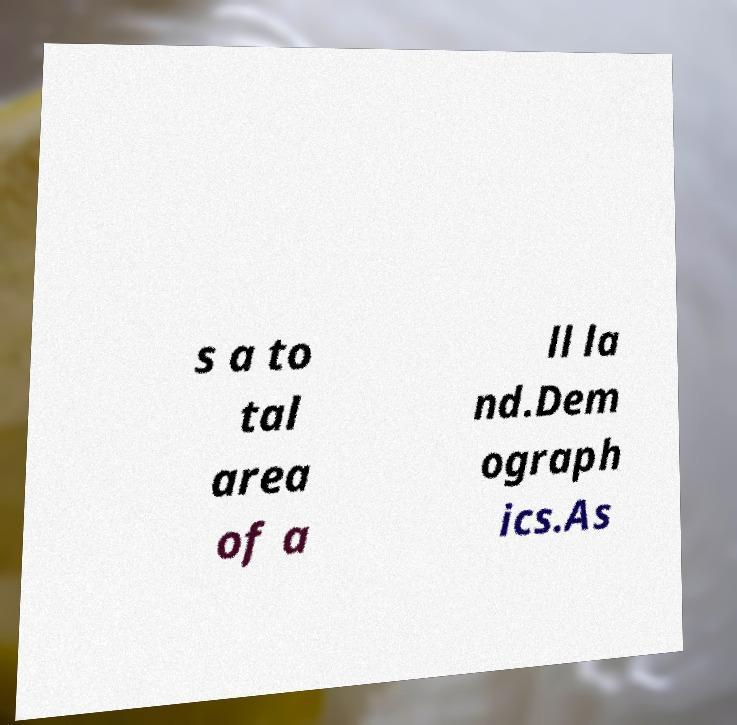Can you read and provide the text displayed in the image?This photo seems to have some interesting text. Can you extract and type it out for me? s a to tal area of a ll la nd.Dem ograph ics.As 